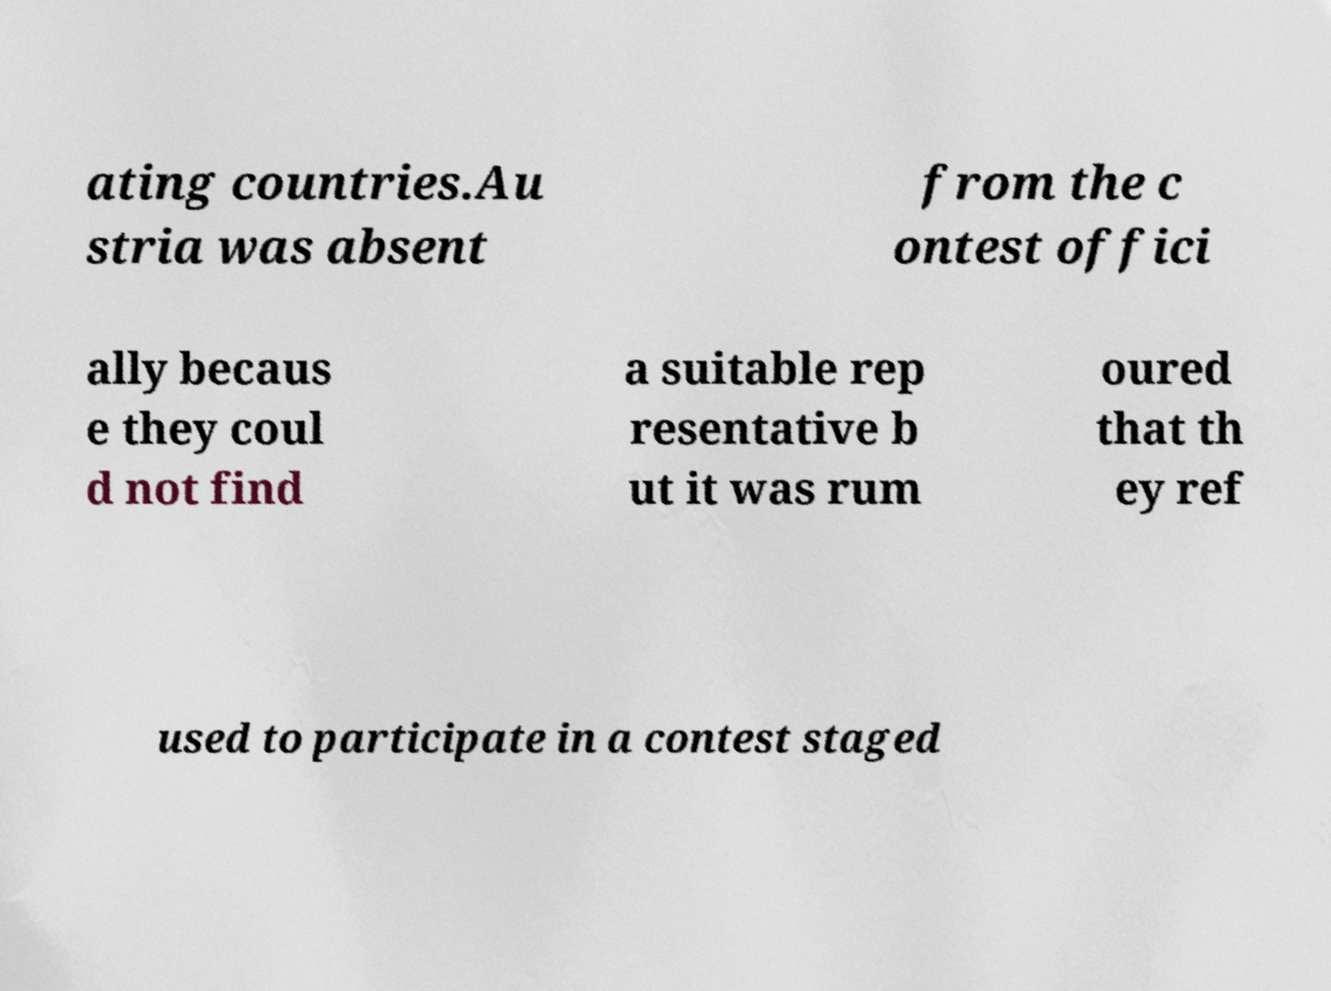Please read and relay the text visible in this image. What does it say? ating countries.Au stria was absent from the c ontest offici ally becaus e they coul d not find a suitable rep resentative b ut it was rum oured that th ey ref used to participate in a contest staged 